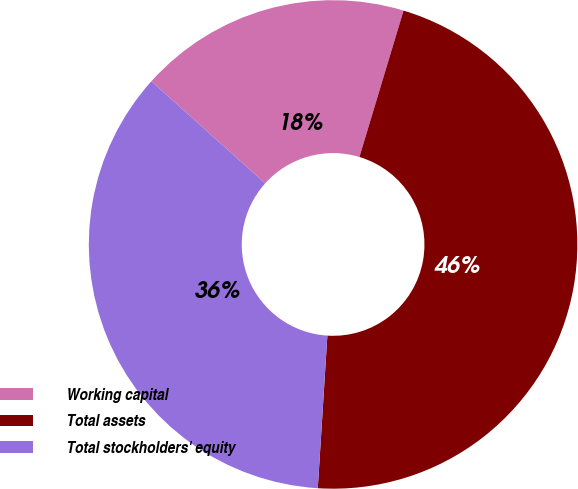<chart> <loc_0><loc_0><loc_500><loc_500><pie_chart><fcel>Working capital<fcel>Total assets<fcel>Total stockholders' equity<nl><fcel>18.01%<fcel>46.34%<fcel>35.65%<nl></chart> 